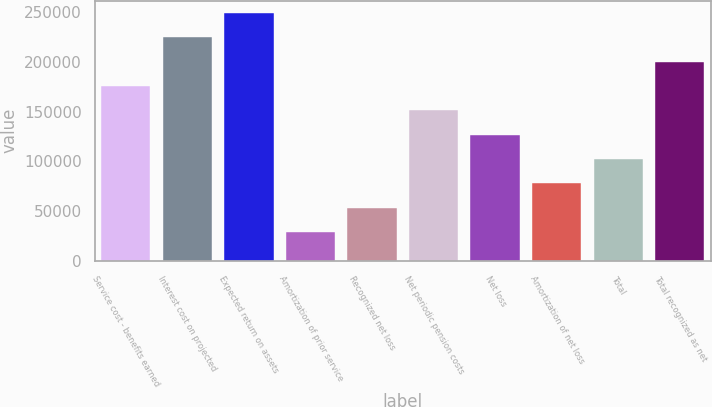Convert chart to OTSL. <chart><loc_0><loc_0><loc_500><loc_500><bar_chart><fcel>Service cost - benefits earned<fcel>Interest cost on projected<fcel>Expected return on assets<fcel>Amortization of prior service<fcel>Recognized net loss<fcel>Net periodic pension costs<fcel>Net loss<fcel>Amortization of net loss<fcel>Total<fcel>Total recognized as net<nl><fcel>175851<fcel>224764<fcel>249220<fcel>29114.2<fcel>53570.4<fcel>151395<fcel>126939<fcel>78026.6<fcel>102483<fcel>200308<nl></chart> 